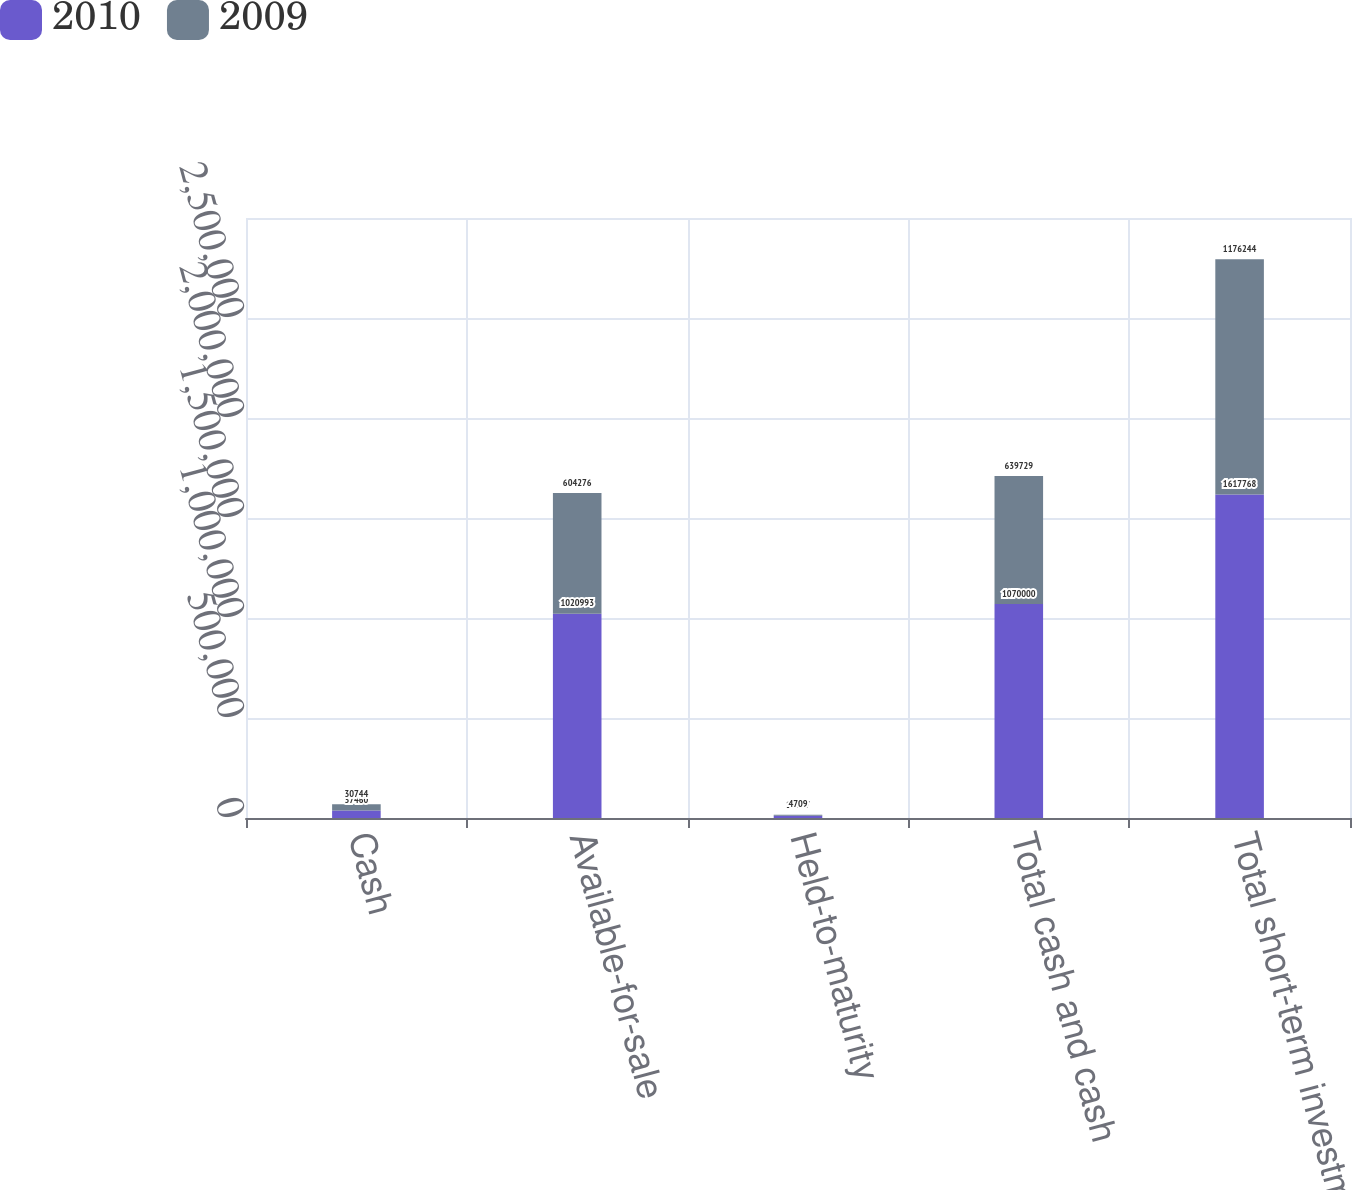Convert chart to OTSL. <chart><loc_0><loc_0><loc_500><loc_500><stacked_bar_chart><ecel><fcel>Cash<fcel>Available-for-sale<fcel>Held-to-maturity<fcel>Total cash and cash<fcel>Total short-term investments<nl><fcel>2010<fcel>37460<fcel>1.02099e+06<fcel>11547<fcel>1.07e+06<fcel>1.61777e+06<nl><fcel>2009<fcel>30744<fcel>604276<fcel>4709<fcel>639729<fcel>1.17624e+06<nl></chart> 